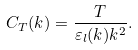<formula> <loc_0><loc_0><loc_500><loc_500>C _ { T } ( k ) = \frac { T } { \varepsilon _ { l } ( k ) k ^ { 2 } } .</formula> 